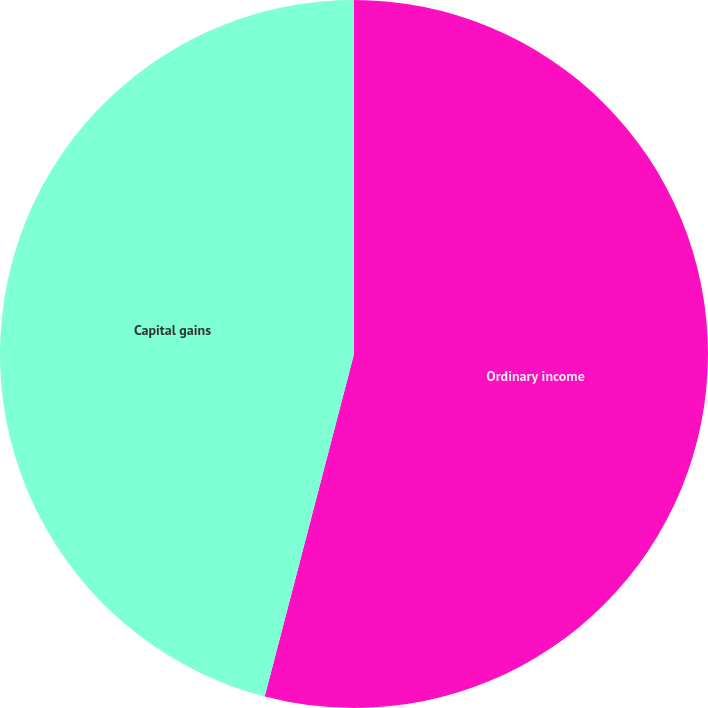Convert chart. <chart><loc_0><loc_0><loc_500><loc_500><pie_chart><fcel>Ordinary income<fcel>Capital gains<nl><fcel>54.06%<fcel>45.94%<nl></chart> 